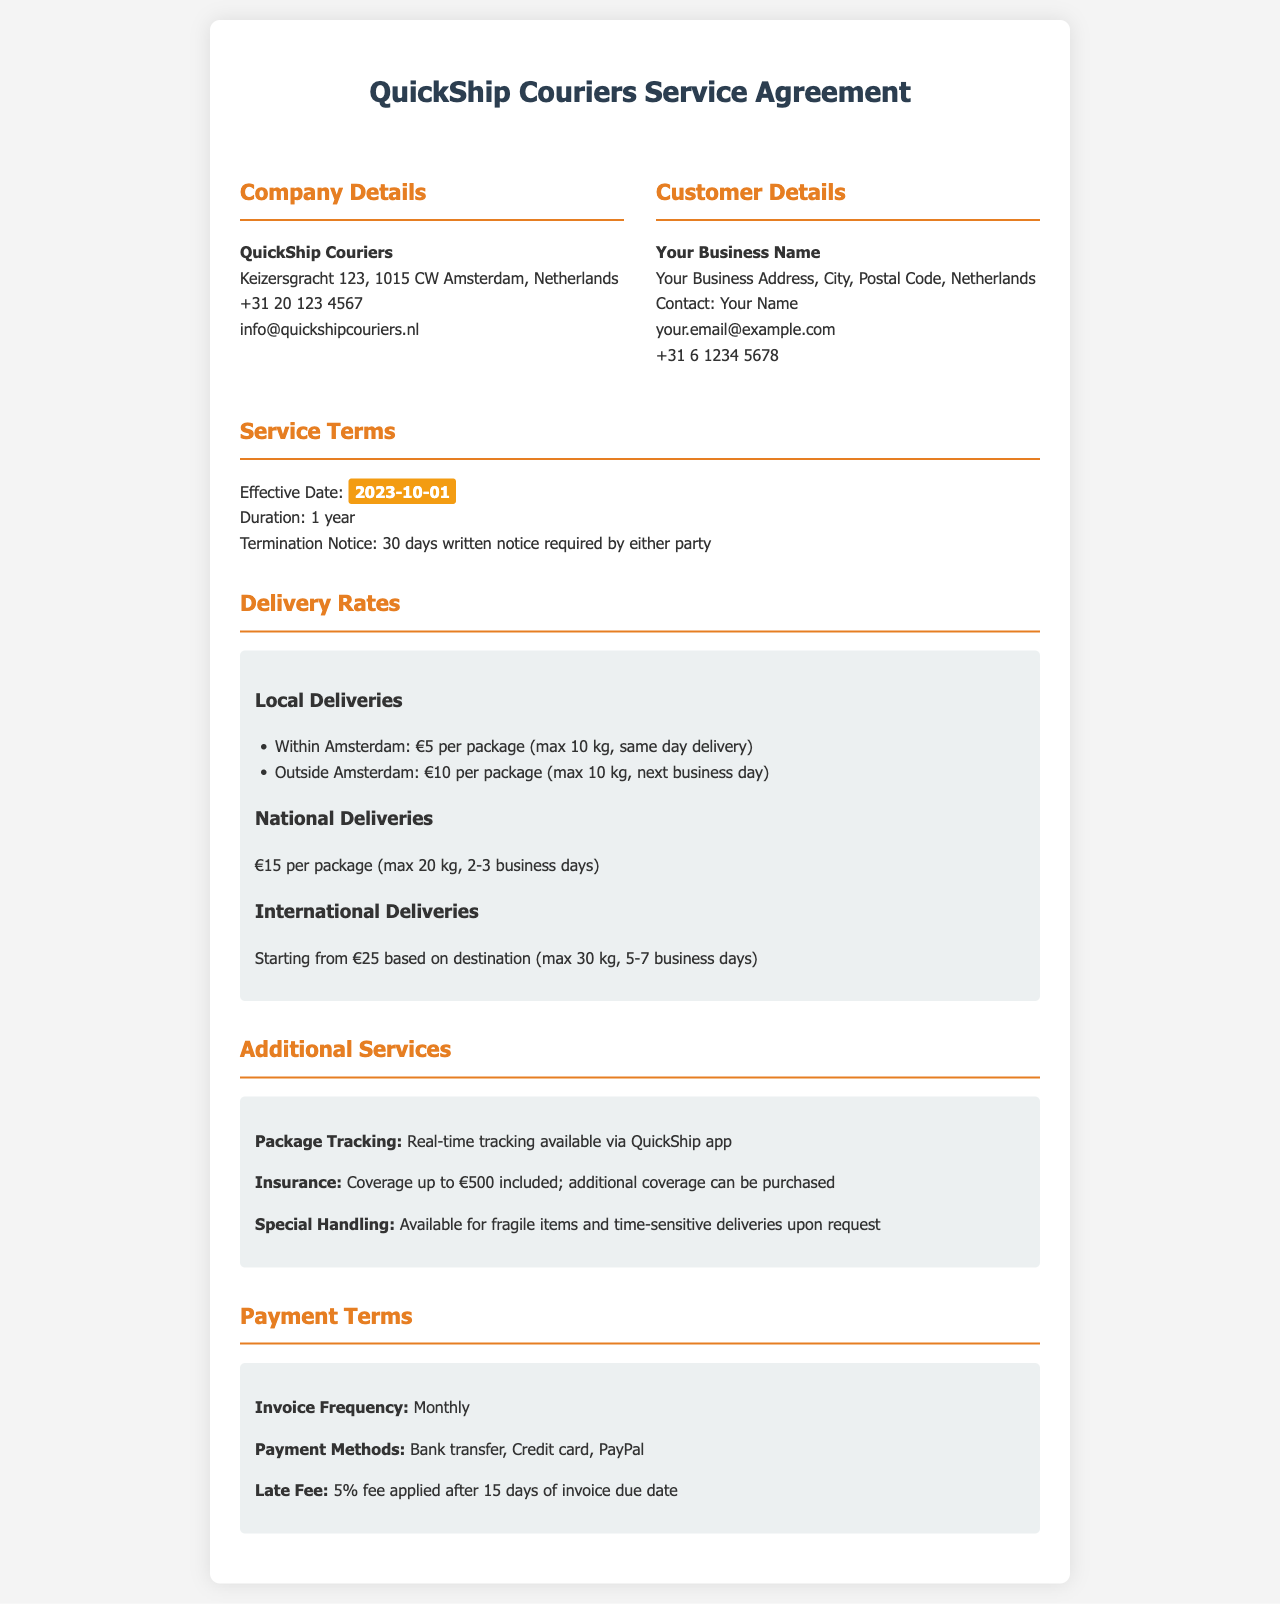What is the effective date of the service agreement? The effective date is specified in the "Service Terms" section of the document.
Answer: 2023-10-01 What is the cost for a package delivered within Amsterdam? This information is available in the "Delivery Rates" section, specifically under "Local Deliveries."
Answer: €5 per package What is the maximum weight for a national delivery? The maximum weight limit is mentioned in the details for national deliveries in the document.
Answer: 20 kg How long does it take for international deliveries? The delivery time for international shipments is outlined in the "Delivery Rates" section.
Answer: 5-7 business days What are the payment methods accepted by QuickShip? The accepted payment methods are listed in the "Payment Terms" section of the document.
Answer: Bank transfer, Credit card, PayPal What is the late fee percentage applied? The percentage for late fees is specified in the "Payment Terms" section of the document.
Answer: 5% What is required to terminate the service agreement? The document states the conditions for termination in the "Service Terms" section.
Answer: 30 days written notice What additional coverage is available for insurance? The document describes insurance features in the "Additional Services" section, detailing coverage options.
Answer: Additional coverage can be purchased What is included with the package tracking feature? The details about package tracking can be found in the "Additional Services" section of the document.
Answer: Real-time tracking available via QuickShip app 